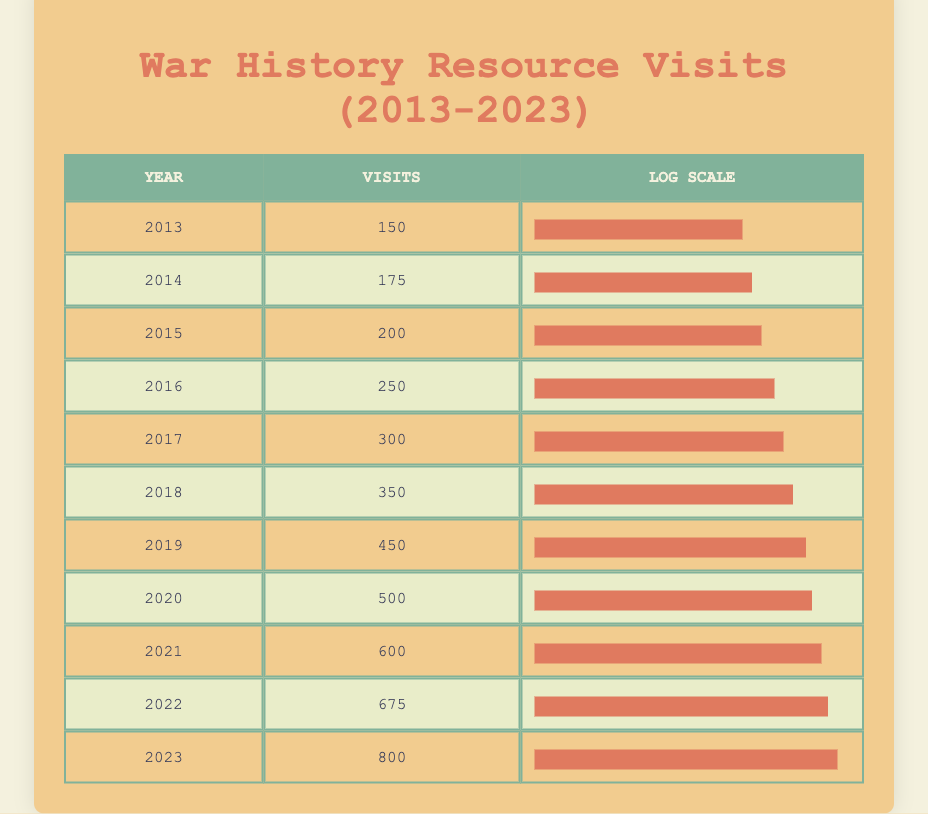What was the number of patron visits for war history resources in 2020? Looking at the table, the row for the year 2020 indicates that there were 500 visits.
Answer: 500 In which year did patron visits first exceed 300? The table shows that visits exceeded 300 for the first time in 2017, as the previous year's total (2016) was 250.
Answer: 2017 What is the total number of visits from 2013 to 2015? To find the total, we sum the visits for 2013 (150), 2014 (175), and 2015 (200): 150 + 175 + 200 = 525.
Answer: 525 Is it true that the number of visits in 2022 was greater than in 2019? Looking at the table, the visits in 2022 were 675, while in 2019 they were 450, confirming that the visits in 2022 were indeed greater.
Answer: Yes What was the percentage increase in patron visits from 2016 to 2023? The visits in 2016 were 250 and in 2023 were 800. The increase is 800 - 250 = 550. Then we calculate the percentage increase: (550 / 250) * 100 = 220%.
Answer: 220% What is the average number of patron visits per year from 2013 to 2023? We total the visits from all years: 150 + 175 + 200 + 250 + 300 + 350 + 450 + 500 + 600 + 675 + 800 = 4175. There are 11 years, so the average is 4175 / 11 ≈ 379.55, which rounds to 380.
Answer: 380 In which year did the highest number of visits occur? By scanning the last column of the table, 2023 shows the highest number of visits at 800.
Answer: 2023 What is the difference in the number of visits between 2018 and 2020? The visits in 2018 were 350 while in 2020 they were 500. The difference is 500 - 350 = 150.
Answer: 150 